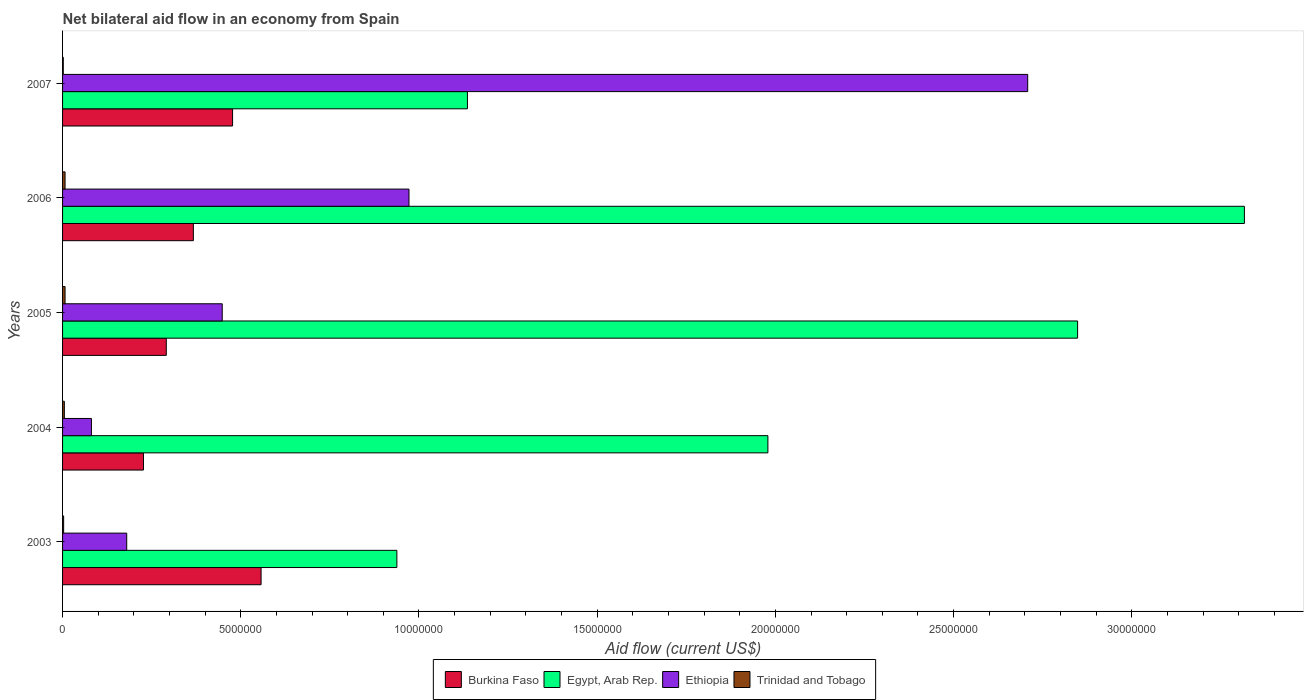How many different coloured bars are there?
Ensure brevity in your answer.  4. How many groups of bars are there?
Provide a short and direct response. 5. Are the number of bars on each tick of the Y-axis equal?
Offer a very short reply. Yes. How many bars are there on the 4th tick from the bottom?
Offer a terse response. 4. What is the net bilateral aid flow in Trinidad and Tobago in 2006?
Provide a short and direct response. 7.00e+04. Across all years, what is the maximum net bilateral aid flow in Egypt, Arab Rep.?
Your answer should be very brief. 3.32e+07. Across all years, what is the minimum net bilateral aid flow in Egypt, Arab Rep.?
Give a very brief answer. 9.38e+06. In which year was the net bilateral aid flow in Burkina Faso maximum?
Give a very brief answer. 2003. What is the total net bilateral aid flow in Egypt, Arab Rep. in the graph?
Your answer should be compact. 1.02e+08. What is the difference between the net bilateral aid flow in Ethiopia in 2004 and the net bilateral aid flow in Egypt, Arab Rep. in 2006?
Offer a very short reply. -3.24e+07. What is the average net bilateral aid flow in Ethiopia per year?
Offer a terse response. 8.78e+06. In the year 2004, what is the difference between the net bilateral aid flow in Burkina Faso and net bilateral aid flow in Trinidad and Tobago?
Provide a succinct answer. 2.22e+06. What is the ratio of the net bilateral aid flow in Burkina Faso in 2003 to that in 2006?
Keep it short and to the point. 1.52. Is the net bilateral aid flow in Ethiopia in 2004 less than that in 2005?
Your response must be concise. Yes. What is the difference between the highest and the second highest net bilateral aid flow in Ethiopia?
Your answer should be very brief. 1.74e+07. What is the difference between the highest and the lowest net bilateral aid flow in Ethiopia?
Offer a terse response. 2.63e+07. Is the sum of the net bilateral aid flow in Burkina Faso in 2003 and 2005 greater than the maximum net bilateral aid flow in Egypt, Arab Rep. across all years?
Your response must be concise. No. What does the 2nd bar from the top in 2003 represents?
Provide a succinct answer. Ethiopia. What does the 1st bar from the bottom in 2005 represents?
Your answer should be very brief. Burkina Faso. Is it the case that in every year, the sum of the net bilateral aid flow in Egypt, Arab Rep. and net bilateral aid flow in Burkina Faso is greater than the net bilateral aid flow in Trinidad and Tobago?
Your response must be concise. Yes. How many bars are there?
Ensure brevity in your answer.  20. What is the difference between two consecutive major ticks on the X-axis?
Your response must be concise. 5.00e+06. Where does the legend appear in the graph?
Your answer should be very brief. Bottom center. How many legend labels are there?
Provide a succinct answer. 4. What is the title of the graph?
Make the answer very short. Net bilateral aid flow in an economy from Spain. Does "Cuba" appear as one of the legend labels in the graph?
Make the answer very short. No. What is the label or title of the X-axis?
Provide a short and direct response. Aid flow (current US$). What is the label or title of the Y-axis?
Provide a short and direct response. Years. What is the Aid flow (current US$) of Burkina Faso in 2003?
Your answer should be compact. 5.57e+06. What is the Aid flow (current US$) of Egypt, Arab Rep. in 2003?
Offer a very short reply. 9.38e+06. What is the Aid flow (current US$) of Ethiopia in 2003?
Offer a terse response. 1.80e+06. What is the Aid flow (current US$) of Burkina Faso in 2004?
Provide a succinct answer. 2.27e+06. What is the Aid flow (current US$) in Egypt, Arab Rep. in 2004?
Make the answer very short. 1.98e+07. What is the Aid flow (current US$) in Ethiopia in 2004?
Ensure brevity in your answer.  8.10e+05. What is the Aid flow (current US$) in Trinidad and Tobago in 2004?
Your response must be concise. 5.00e+04. What is the Aid flow (current US$) in Burkina Faso in 2005?
Give a very brief answer. 2.91e+06. What is the Aid flow (current US$) in Egypt, Arab Rep. in 2005?
Offer a terse response. 2.85e+07. What is the Aid flow (current US$) of Ethiopia in 2005?
Make the answer very short. 4.48e+06. What is the Aid flow (current US$) in Burkina Faso in 2006?
Your response must be concise. 3.67e+06. What is the Aid flow (current US$) in Egypt, Arab Rep. in 2006?
Provide a short and direct response. 3.32e+07. What is the Aid flow (current US$) of Ethiopia in 2006?
Offer a very short reply. 9.72e+06. What is the Aid flow (current US$) of Burkina Faso in 2007?
Offer a very short reply. 4.77e+06. What is the Aid flow (current US$) in Egypt, Arab Rep. in 2007?
Offer a very short reply. 1.14e+07. What is the Aid flow (current US$) in Ethiopia in 2007?
Keep it short and to the point. 2.71e+07. What is the Aid flow (current US$) of Trinidad and Tobago in 2007?
Your answer should be very brief. 2.00e+04. Across all years, what is the maximum Aid flow (current US$) of Burkina Faso?
Your answer should be very brief. 5.57e+06. Across all years, what is the maximum Aid flow (current US$) in Egypt, Arab Rep.?
Offer a terse response. 3.32e+07. Across all years, what is the maximum Aid flow (current US$) in Ethiopia?
Make the answer very short. 2.71e+07. Across all years, what is the maximum Aid flow (current US$) of Trinidad and Tobago?
Give a very brief answer. 7.00e+04. Across all years, what is the minimum Aid flow (current US$) of Burkina Faso?
Keep it short and to the point. 2.27e+06. Across all years, what is the minimum Aid flow (current US$) of Egypt, Arab Rep.?
Your answer should be compact. 9.38e+06. Across all years, what is the minimum Aid flow (current US$) in Ethiopia?
Ensure brevity in your answer.  8.10e+05. Across all years, what is the minimum Aid flow (current US$) in Trinidad and Tobago?
Your answer should be very brief. 2.00e+04. What is the total Aid flow (current US$) of Burkina Faso in the graph?
Your response must be concise. 1.92e+07. What is the total Aid flow (current US$) in Egypt, Arab Rep. in the graph?
Offer a very short reply. 1.02e+08. What is the total Aid flow (current US$) in Ethiopia in the graph?
Keep it short and to the point. 4.39e+07. What is the total Aid flow (current US$) of Trinidad and Tobago in the graph?
Keep it short and to the point. 2.40e+05. What is the difference between the Aid flow (current US$) in Burkina Faso in 2003 and that in 2004?
Offer a terse response. 3.30e+06. What is the difference between the Aid flow (current US$) in Egypt, Arab Rep. in 2003 and that in 2004?
Ensure brevity in your answer.  -1.04e+07. What is the difference between the Aid flow (current US$) of Ethiopia in 2003 and that in 2004?
Ensure brevity in your answer.  9.90e+05. What is the difference between the Aid flow (current US$) in Burkina Faso in 2003 and that in 2005?
Your answer should be very brief. 2.66e+06. What is the difference between the Aid flow (current US$) in Egypt, Arab Rep. in 2003 and that in 2005?
Give a very brief answer. -1.91e+07. What is the difference between the Aid flow (current US$) in Ethiopia in 2003 and that in 2005?
Make the answer very short. -2.68e+06. What is the difference between the Aid flow (current US$) of Burkina Faso in 2003 and that in 2006?
Make the answer very short. 1.90e+06. What is the difference between the Aid flow (current US$) of Egypt, Arab Rep. in 2003 and that in 2006?
Give a very brief answer. -2.38e+07. What is the difference between the Aid flow (current US$) of Ethiopia in 2003 and that in 2006?
Your answer should be very brief. -7.92e+06. What is the difference between the Aid flow (current US$) of Trinidad and Tobago in 2003 and that in 2006?
Make the answer very short. -4.00e+04. What is the difference between the Aid flow (current US$) in Burkina Faso in 2003 and that in 2007?
Your response must be concise. 8.00e+05. What is the difference between the Aid flow (current US$) in Egypt, Arab Rep. in 2003 and that in 2007?
Make the answer very short. -1.98e+06. What is the difference between the Aid flow (current US$) in Ethiopia in 2003 and that in 2007?
Provide a succinct answer. -2.53e+07. What is the difference between the Aid flow (current US$) of Trinidad and Tobago in 2003 and that in 2007?
Provide a short and direct response. 10000. What is the difference between the Aid flow (current US$) of Burkina Faso in 2004 and that in 2005?
Provide a succinct answer. -6.40e+05. What is the difference between the Aid flow (current US$) in Egypt, Arab Rep. in 2004 and that in 2005?
Offer a very short reply. -8.69e+06. What is the difference between the Aid flow (current US$) in Ethiopia in 2004 and that in 2005?
Keep it short and to the point. -3.67e+06. What is the difference between the Aid flow (current US$) of Burkina Faso in 2004 and that in 2006?
Provide a short and direct response. -1.40e+06. What is the difference between the Aid flow (current US$) of Egypt, Arab Rep. in 2004 and that in 2006?
Ensure brevity in your answer.  -1.34e+07. What is the difference between the Aid flow (current US$) of Ethiopia in 2004 and that in 2006?
Your answer should be compact. -8.91e+06. What is the difference between the Aid flow (current US$) of Trinidad and Tobago in 2004 and that in 2006?
Keep it short and to the point. -2.00e+04. What is the difference between the Aid flow (current US$) in Burkina Faso in 2004 and that in 2007?
Provide a succinct answer. -2.50e+06. What is the difference between the Aid flow (current US$) in Egypt, Arab Rep. in 2004 and that in 2007?
Your response must be concise. 8.43e+06. What is the difference between the Aid flow (current US$) of Ethiopia in 2004 and that in 2007?
Your response must be concise. -2.63e+07. What is the difference between the Aid flow (current US$) in Trinidad and Tobago in 2004 and that in 2007?
Ensure brevity in your answer.  3.00e+04. What is the difference between the Aid flow (current US$) of Burkina Faso in 2005 and that in 2006?
Your answer should be compact. -7.60e+05. What is the difference between the Aid flow (current US$) in Egypt, Arab Rep. in 2005 and that in 2006?
Your answer should be very brief. -4.68e+06. What is the difference between the Aid flow (current US$) of Ethiopia in 2005 and that in 2006?
Make the answer very short. -5.24e+06. What is the difference between the Aid flow (current US$) of Burkina Faso in 2005 and that in 2007?
Keep it short and to the point. -1.86e+06. What is the difference between the Aid flow (current US$) in Egypt, Arab Rep. in 2005 and that in 2007?
Ensure brevity in your answer.  1.71e+07. What is the difference between the Aid flow (current US$) of Ethiopia in 2005 and that in 2007?
Ensure brevity in your answer.  -2.26e+07. What is the difference between the Aid flow (current US$) of Burkina Faso in 2006 and that in 2007?
Your answer should be very brief. -1.10e+06. What is the difference between the Aid flow (current US$) of Egypt, Arab Rep. in 2006 and that in 2007?
Ensure brevity in your answer.  2.18e+07. What is the difference between the Aid flow (current US$) of Ethiopia in 2006 and that in 2007?
Keep it short and to the point. -1.74e+07. What is the difference between the Aid flow (current US$) in Trinidad and Tobago in 2006 and that in 2007?
Your response must be concise. 5.00e+04. What is the difference between the Aid flow (current US$) in Burkina Faso in 2003 and the Aid flow (current US$) in Egypt, Arab Rep. in 2004?
Your answer should be very brief. -1.42e+07. What is the difference between the Aid flow (current US$) of Burkina Faso in 2003 and the Aid flow (current US$) of Ethiopia in 2004?
Your answer should be very brief. 4.76e+06. What is the difference between the Aid flow (current US$) in Burkina Faso in 2003 and the Aid flow (current US$) in Trinidad and Tobago in 2004?
Provide a short and direct response. 5.52e+06. What is the difference between the Aid flow (current US$) in Egypt, Arab Rep. in 2003 and the Aid flow (current US$) in Ethiopia in 2004?
Your response must be concise. 8.57e+06. What is the difference between the Aid flow (current US$) of Egypt, Arab Rep. in 2003 and the Aid flow (current US$) of Trinidad and Tobago in 2004?
Give a very brief answer. 9.33e+06. What is the difference between the Aid flow (current US$) in Ethiopia in 2003 and the Aid flow (current US$) in Trinidad and Tobago in 2004?
Make the answer very short. 1.75e+06. What is the difference between the Aid flow (current US$) in Burkina Faso in 2003 and the Aid flow (current US$) in Egypt, Arab Rep. in 2005?
Offer a terse response. -2.29e+07. What is the difference between the Aid flow (current US$) in Burkina Faso in 2003 and the Aid flow (current US$) in Ethiopia in 2005?
Ensure brevity in your answer.  1.09e+06. What is the difference between the Aid flow (current US$) in Burkina Faso in 2003 and the Aid flow (current US$) in Trinidad and Tobago in 2005?
Offer a terse response. 5.50e+06. What is the difference between the Aid flow (current US$) of Egypt, Arab Rep. in 2003 and the Aid flow (current US$) of Ethiopia in 2005?
Make the answer very short. 4.90e+06. What is the difference between the Aid flow (current US$) in Egypt, Arab Rep. in 2003 and the Aid flow (current US$) in Trinidad and Tobago in 2005?
Offer a very short reply. 9.31e+06. What is the difference between the Aid flow (current US$) in Ethiopia in 2003 and the Aid flow (current US$) in Trinidad and Tobago in 2005?
Offer a very short reply. 1.73e+06. What is the difference between the Aid flow (current US$) of Burkina Faso in 2003 and the Aid flow (current US$) of Egypt, Arab Rep. in 2006?
Offer a terse response. -2.76e+07. What is the difference between the Aid flow (current US$) of Burkina Faso in 2003 and the Aid flow (current US$) of Ethiopia in 2006?
Ensure brevity in your answer.  -4.15e+06. What is the difference between the Aid flow (current US$) in Burkina Faso in 2003 and the Aid flow (current US$) in Trinidad and Tobago in 2006?
Provide a short and direct response. 5.50e+06. What is the difference between the Aid flow (current US$) in Egypt, Arab Rep. in 2003 and the Aid flow (current US$) in Ethiopia in 2006?
Ensure brevity in your answer.  -3.40e+05. What is the difference between the Aid flow (current US$) in Egypt, Arab Rep. in 2003 and the Aid flow (current US$) in Trinidad and Tobago in 2006?
Ensure brevity in your answer.  9.31e+06. What is the difference between the Aid flow (current US$) in Ethiopia in 2003 and the Aid flow (current US$) in Trinidad and Tobago in 2006?
Make the answer very short. 1.73e+06. What is the difference between the Aid flow (current US$) of Burkina Faso in 2003 and the Aid flow (current US$) of Egypt, Arab Rep. in 2007?
Make the answer very short. -5.79e+06. What is the difference between the Aid flow (current US$) in Burkina Faso in 2003 and the Aid flow (current US$) in Ethiopia in 2007?
Give a very brief answer. -2.15e+07. What is the difference between the Aid flow (current US$) in Burkina Faso in 2003 and the Aid flow (current US$) in Trinidad and Tobago in 2007?
Provide a succinct answer. 5.55e+06. What is the difference between the Aid flow (current US$) of Egypt, Arab Rep. in 2003 and the Aid flow (current US$) of Ethiopia in 2007?
Offer a very short reply. -1.77e+07. What is the difference between the Aid flow (current US$) of Egypt, Arab Rep. in 2003 and the Aid flow (current US$) of Trinidad and Tobago in 2007?
Provide a succinct answer. 9.36e+06. What is the difference between the Aid flow (current US$) of Ethiopia in 2003 and the Aid flow (current US$) of Trinidad and Tobago in 2007?
Provide a succinct answer. 1.78e+06. What is the difference between the Aid flow (current US$) in Burkina Faso in 2004 and the Aid flow (current US$) in Egypt, Arab Rep. in 2005?
Make the answer very short. -2.62e+07. What is the difference between the Aid flow (current US$) in Burkina Faso in 2004 and the Aid flow (current US$) in Ethiopia in 2005?
Offer a terse response. -2.21e+06. What is the difference between the Aid flow (current US$) in Burkina Faso in 2004 and the Aid flow (current US$) in Trinidad and Tobago in 2005?
Your response must be concise. 2.20e+06. What is the difference between the Aid flow (current US$) in Egypt, Arab Rep. in 2004 and the Aid flow (current US$) in Ethiopia in 2005?
Provide a succinct answer. 1.53e+07. What is the difference between the Aid flow (current US$) in Egypt, Arab Rep. in 2004 and the Aid flow (current US$) in Trinidad and Tobago in 2005?
Your response must be concise. 1.97e+07. What is the difference between the Aid flow (current US$) of Ethiopia in 2004 and the Aid flow (current US$) of Trinidad and Tobago in 2005?
Your answer should be compact. 7.40e+05. What is the difference between the Aid flow (current US$) in Burkina Faso in 2004 and the Aid flow (current US$) in Egypt, Arab Rep. in 2006?
Provide a short and direct response. -3.09e+07. What is the difference between the Aid flow (current US$) in Burkina Faso in 2004 and the Aid flow (current US$) in Ethiopia in 2006?
Provide a succinct answer. -7.45e+06. What is the difference between the Aid flow (current US$) of Burkina Faso in 2004 and the Aid flow (current US$) of Trinidad and Tobago in 2006?
Your answer should be compact. 2.20e+06. What is the difference between the Aid flow (current US$) of Egypt, Arab Rep. in 2004 and the Aid flow (current US$) of Ethiopia in 2006?
Keep it short and to the point. 1.01e+07. What is the difference between the Aid flow (current US$) of Egypt, Arab Rep. in 2004 and the Aid flow (current US$) of Trinidad and Tobago in 2006?
Provide a succinct answer. 1.97e+07. What is the difference between the Aid flow (current US$) in Ethiopia in 2004 and the Aid flow (current US$) in Trinidad and Tobago in 2006?
Provide a succinct answer. 7.40e+05. What is the difference between the Aid flow (current US$) in Burkina Faso in 2004 and the Aid flow (current US$) in Egypt, Arab Rep. in 2007?
Provide a short and direct response. -9.09e+06. What is the difference between the Aid flow (current US$) in Burkina Faso in 2004 and the Aid flow (current US$) in Ethiopia in 2007?
Your answer should be very brief. -2.48e+07. What is the difference between the Aid flow (current US$) of Burkina Faso in 2004 and the Aid flow (current US$) of Trinidad and Tobago in 2007?
Ensure brevity in your answer.  2.25e+06. What is the difference between the Aid flow (current US$) in Egypt, Arab Rep. in 2004 and the Aid flow (current US$) in Ethiopia in 2007?
Offer a terse response. -7.29e+06. What is the difference between the Aid flow (current US$) in Egypt, Arab Rep. in 2004 and the Aid flow (current US$) in Trinidad and Tobago in 2007?
Your answer should be very brief. 1.98e+07. What is the difference between the Aid flow (current US$) of Ethiopia in 2004 and the Aid flow (current US$) of Trinidad and Tobago in 2007?
Keep it short and to the point. 7.90e+05. What is the difference between the Aid flow (current US$) in Burkina Faso in 2005 and the Aid flow (current US$) in Egypt, Arab Rep. in 2006?
Give a very brief answer. -3.02e+07. What is the difference between the Aid flow (current US$) of Burkina Faso in 2005 and the Aid flow (current US$) of Ethiopia in 2006?
Provide a succinct answer. -6.81e+06. What is the difference between the Aid flow (current US$) in Burkina Faso in 2005 and the Aid flow (current US$) in Trinidad and Tobago in 2006?
Your response must be concise. 2.84e+06. What is the difference between the Aid flow (current US$) of Egypt, Arab Rep. in 2005 and the Aid flow (current US$) of Ethiopia in 2006?
Offer a very short reply. 1.88e+07. What is the difference between the Aid flow (current US$) in Egypt, Arab Rep. in 2005 and the Aid flow (current US$) in Trinidad and Tobago in 2006?
Give a very brief answer. 2.84e+07. What is the difference between the Aid flow (current US$) in Ethiopia in 2005 and the Aid flow (current US$) in Trinidad and Tobago in 2006?
Provide a succinct answer. 4.41e+06. What is the difference between the Aid flow (current US$) of Burkina Faso in 2005 and the Aid flow (current US$) of Egypt, Arab Rep. in 2007?
Your answer should be compact. -8.45e+06. What is the difference between the Aid flow (current US$) of Burkina Faso in 2005 and the Aid flow (current US$) of Ethiopia in 2007?
Your answer should be compact. -2.42e+07. What is the difference between the Aid flow (current US$) of Burkina Faso in 2005 and the Aid flow (current US$) of Trinidad and Tobago in 2007?
Your response must be concise. 2.89e+06. What is the difference between the Aid flow (current US$) of Egypt, Arab Rep. in 2005 and the Aid flow (current US$) of Ethiopia in 2007?
Provide a short and direct response. 1.40e+06. What is the difference between the Aid flow (current US$) of Egypt, Arab Rep. in 2005 and the Aid flow (current US$) of Trinidad and Tobago in 2007?
Offer a terse response. 2.85e+07. What is the difference between the Aid flow (current US$) in Ethiopia in 2005 and the Aid flow (current US$) in Trinidad and Tobago in 2007?
Keep it short and to the point. 4.46e+06. What is the difference between the Aid flow (current US$) of Burkina Faso in 2006 and the Aid flow (current US$) of Egypt, Arab Rep. in 2007?
Make the answer very short. -7.69e+06. What is the difference between the Aid flow (current US$) in Burkina Faso in 2006 and the Aid flow (current US$) in Ethiopia in 2007?
Give a very brief answer. -2.34e+07. What is the difference between the Aid flow (current US$) of Burkina Faso in 2006 and the Aid flow (current US$) of Trinidad and Tobago in 2007?
Your answer should be very brief. 3.65e+06. What is the difference between the Aid flow (current US$) of Egypt, Arab Rep. in 2006 and the Aid flow (current US$) of Ethiopia in 2007?
Offer a terse response. 6.08e+06. What is the difference between the Aid flow (current US$) of Egypt, Arab Rep. in 2006 and the Aid flow (current US$) of Trinidad and Tobago in 2007?
Offer a very short reply. 3.31e+07. What is the difference between the Aid flow (current US$) of Ethiopia in 2006 and the Aid flow (current US$) of Trinidad and Tobago in 2007?
Your response must be concise. 9.70e+06. What is the average Aid flow (current US$) in Burkina Faso per year?
Offer a very short reply. 3.84e+06. What is the average Aid flow (current US$) of Egypt, Arab Rep. per year?
Keep it short and to the point. 2.04e+07. What is the average Aid flow (current US$) of Ethiopia per year?
Provide a succinct answer. 8.78e+06. What is the average Aid flow (current US$) in Trinidad and Tobago per year?
Provide a short and direct response. 4.80e+04. In the year 2003, what is the difference between the Aid flow (current US$) of Burkina Faso and Aid flow (current US$) of Egypt, Arab Rep.?
Provide a short and direct response. -3.81e+06. In the year 2003, what is the difference between the Aid flow (current US$) in Burkina Faso and Aid flow (current US$) in Ethiopia?
Provide a succinct answer. 3.77e+06. In the year 2003, what is the difference between the Aid flow (current US$) of Burkina Faso and Aid flow (current US$) of Trinidad and Tobago?
Offer a terse response. 5.54e+06. In the year 2003, what is the difference between the Aid flow (current US$) of Egypt, Arab Rep. and Aid flow (current US$) of Ethiopia?
Your answer should be very brief. 7.58e+06. In the year 2003, what is the difference between the Aid flow (current US$) of Egypt, Arab Rep. and Aid flow (current US$) of Trinidad and Tobago?
Provide a succinct answer. 9.35e+06. In the year 2003, what is the difference between the Aid flow (current US$) of Ethiopia and Aid flow (current US$) of Trinidad and Tobago?
Keep it short and to the point. 1.77e+06. In the year 2004, what is the difference between the Aid flow (current US$) in Burkina Faso and Aid flow (current US$) in Egypt, Arab Rep.?
Provide a succinct answer. -1.75e+07. In the year 2004, what is the difference between the Aid flow (current US$) of Burkina Faso and Aid flow (current US$) of Ethiopia?
Your response must be concise. 1.46e+06. In the year 2004, what is the difference between the Aid flow (current US$) of Burkina Faso and Aid flow (current US$) of Trinidad and Tobago?
Ensure brevity in your answer.  2.22e+06. In the year 2004, what is the difference between the Aid flow (current US$) in Egypt, Arab Rep. and Aid flow (current US$) in Ethiopia?
Give a very brief answer. 1.90e+07. In the year 2004, what is the difference between the Aid flow (current US$) in Egypt, Arab Rep. and Aid flow (current US$) in Trinidad and Tobago?
Give a very brief answer. 1.97e+07. In the year 2004, what is the difference between the Aid flow (current US$) in Ethiopia and Aid flow (current US$) in Trinidad and Tobago?
Make the answer very short. 7.60e+05. In the year 2005, what is the difference between the Aid flow (current US$) of Burkina Faso and Aid flow (current US$) of Egypt, Arab Rep.?
Offer a very short reply. -2.56e+07. In the year 2005, what is the difference between the Aid flow (current US$) of Burkina Faso and Aid flow (current US$) of Ethiopia?
Provide a short and direct response. -1.57e+06. In the year 2005, what is the difference between the Aid flow (current US$) in Burkina Faso and Aid flow (current US$) in Trinidad and Tobago?
Make the answer very short. 2.84e+06. In the year 2005, what is the difference between the Aid flow (current US$) in Egypt, Arab Rep. and Aid flow (current US$) in Ethiopia?
Ensure brevity in your answer.  2.40e+07. In the year 2005, what is the difference between the Aid flow (current US$) in Egypt, Arab Rep. and Aid flow (current US$) in Trinidad and Tobago?
Offer a terse response. 2.84e+07. In the year 2005, what is the difference between the Aid flow (current US$) of Ethiopia and Aid flow (current US$) of Trinidad and Tobago?
Your answer should be very brief. 4.41e+06. In the year 2006, what is the difference between the Aid flow (current US$) of Burkina Faso and Aid flow (current US$) of Egypt, Arab Rep.?
Your response must be concise. -2.95e+07. In the year 2006, what is the difference between the Aid flow (current US$) of Burkina Faso and Aid flow (current US$) of Ethiopia?
Give a very brief answer. -6.05e+06. In the year 2006, what is the difference between the Aid flow (current US$) in Burkina Faso and Aid flow (current US$) in Trinidad and Tobago?
Keep it short and to the point. 3.60e+06. In the year 2006, what is the difference between the Aid flow (current US$) of Egypt, Arab Rep. and Aid flow (current US$) of Ethiopia?
Provide a short and direct response. 2.34e+07. In the year 2006, what is the difference between the Aid flow (current US$) in Egypt, Arab Rep. and Aid flow (current US$) in Trinidad and Tobago?
Your response must be concise. 3.31e+07. In the year 2006, what is the difference between the Aid flow (current US$) in Ethiopia and Aid flow (current US$) in Trinidad and Tobago?
Make the answer very short. 9.65e+06. In the year 2007, what is the difference between the Aid flow (current US$) of Burkina Faso and Aid flow (current US$) of Egypt, Arab Rep.?
Your response must be concise. -6.59e+06. In the year 2007, what is the difference between the Aid flow (current US$) of Burkina Faso and Aid flow (current US$) of Ethiopia?
Your response must be concise. -2.23e+07. In the year 2007, what is the difference between the Aid flow (current US$) of Burkina Faso and Aid flow (current US$) of Trinidad and Tobago?
Provide a succinct answer. 4.75e+06. In the year 2007, what is the difference between the Aid flow (current US$) of Egypt, Arab Rep. and Aid flow (current US$) of Ethiopia?
Your response must be concise. -1.57e+07. In the year 2007, what is the difference between the Aid flow (current US$) in Egypt, Arab Rep. and Aid flow (current US$) in Trinidad and Tobago?
Offer a very short reply. 1.13e+07. In the year 2007, what is the difference between the Aid flow (current US$) in Ethiopia and Aid flow (current US$) in Trinidad and Tobago?
Give a very brief answer. 2.71e+07. What is the ratio of the Aid flow (current US$) in Burkina Faso in 2003 to that in 2004?
Offer a terse response. 2.45. What is the ratio of the Aid flow (current US$) of Egypt, Arab Rep. in 2003 to that in 2004?
Keep it short and to the point. 0.47. What is the ratio of the Aid flow (current US$) of Ethiopia in 2003 to that in 2004?
Provide a succinct answer. 2.22. What is the ratio of the Aid flow (current US$) in Burkina Faso in 2003 to that in 2005?
Provide a short and direct response. 1.91. What is the ratio of the Aid flow (current US$) of Egypt, Arab Rep. in 2003 to that in 2005?
Your answer should be very brief. 0.33. What is the ratio of the Aid flow (current US$) in Ethiopia in 2003 to that in 2005?
Keep it short and to the point. 0.4. What is the ratio of the Aid flow (current US$) of Trinidad and Tobago in 2003 to that in 2005?
Offer a terse response. 0.43. What is the ratio of the Aid flow (current US$) of Burkina Faso in 2003 to that in 2006?
Offer a terse response. 1.52. What is the ratio of the Aid flow (current US$) in Egypt, Arab Rep. in 2003 to that in 2006?
Provide a succinct answer. 0.28. What is the ratio of the Aid flow (current US$) in Ethiopia in 2003 to that in 2006?
Give a very brief answer. 0.19. What is the ratio of the Aid flow (current US$) in Trinidad and Tobago in 2003 to that in 2006?
Ensure brevity in your answer.  0.43. What is the ratio of the Aid flow (current US$) of Burkina Faso in 2003 to that in 2007?
Offer a terse response. 1.17. What is the ratio of the Aid flow (current US$) in Egypt, Arab Rep. in 2003 to that in 2007?
Ensure brevity in your answer.  0.83. What is the ratio of the Aid flow (current US$) in Ethiopia in 2003 to that in 2007?
Offer a terse response. 0.07. What is the ratio of the Aid flow (current US$) in Burkina Faso in 2004 to that in 2005?
Offer a very short reply. 0.78. What is the ratio of the Aid flow (current US$) of Egypt, Arab Rep. in 2004 to that in 2005?
Offer a terse response. 0.69. What is the ratio of the Aid flow (current US$) in Ethiopia in 2004 to that in 2005?
Provide a succinct answer. 0.18. What is the ratio of the Aid flow (current US$) in Burkina Faso in 2004 to that in 2006?
Provide a succinct answer. 0.62. What is the ratio of the Aid flow (current US$) in Egypt, Arab Rep. in 2004 to that in 2006?
Give a very brief answer. 0.6. What is the ratio of the Aid flow (current US$) of Ethiopia in 2004 to that in 2006?
Provide a short and direct response. 0.08. What is the ratio of the Aid flow (current US$) of Trinidad and Tobago in 2004 to that in 2006?
Make the answer very short. 0.71. What is the ratio of the Aid flow (current US$) in Burkina Faso in 2004 to that in 2007?
Your response must be concise. 0.48. What is the ratio of the Aid flow (current US$) in Egypt, Arab Rep. in 2004 to that in 2007?
Provide a short and direct response. 1.74. What is the ratio of the Aid flow (current US$) of Ethiopia in 2004 to that in 2007?
Provide a succinct answer. 0.03. What is the ratio of the Aid flow (current US$) of Trinidad and Tobago in 2004 to that in 2007?
Your answer should be very brief. 2.5. What is the ratio of the Aid flow (current US$) in Burkina Faso in 2005 to that in 2006?
Your answer should be compact. 0.79. What is the ratio of the Aid flow (current US$) of Egypt, Arab Rep. in 2005 to that in 2006?
Offer a very short reply. 0.86. What is the ratio of the Aid flow (current US$) in Ethiopia in 2005 to that in 2006?
Provide a succinct answer. 0.46. What is the ratio of the Aid flow (current US$) of Trinidad and Tobago in 2005 to that in 2006?
Ensure brevity in your answer.  1. What is the ratio of the Aid flow (current US$) of Burkina Faso in 2005 to that in 2007?
Your response must be concise. 0.61. What is the ratio of the Aid flow (current US$) in Egypt, Arab Rep. in 2005 to that in 2007?
Your response must be concise. 2.51. What is the ratio of the Aid flow (current US$) in Ethiopia in 2005 to that in 2007?
Provide a succinct answer. 0.17. What is the ratio of the Aid flow (current US$) in Trinidad and Tobago in 2005 to that in 2007?
Offer a very short reply. 3.5. What is the ratio of the Aid flow (current US$) of Burkina Faso in 2006 to that in 2007?
Provide a short and direct response. 0.77. What is the ratio of the Aid flow (current US$) in Egypt, Arab Rep. in 2006 to that in 2007?
Ensure brevity in your answer.  2.92. What is the ratio of the Aid flow (current US$) in Ethiopia in 2006 to that in 2007?
Offer a very short reply. 0.36. What is the ratio of the Aid flow (current US$) in Trinidad and Tobago in 2006 to that in 2007?
Provide a short and direct response. 3.5. What is the difference between the highest and the second highest Aid flow (current US$) of Egypt, Arab Rep.?
Make the answer very short. 4.68e+06. What is the difference between the highest and the second highest Aid flow (current US$) in Ethiopia?
Make the answer very short. 1.74e+07. What is the difference between the highest and the lowest Aid flow (current US$) of Burkina Faso?
Provide a short and direct response. 3.30e+06. What is the difference between the highest and the lowest Aid flow (current US$) in Egypt, Arab Rep.?
Your answer should be very brief. 2.38e+07. What is the difference between the highest and the lowest Aid flow (current US$) in Ethiopia?
Provide a short and direct response. 2.63e+07. 